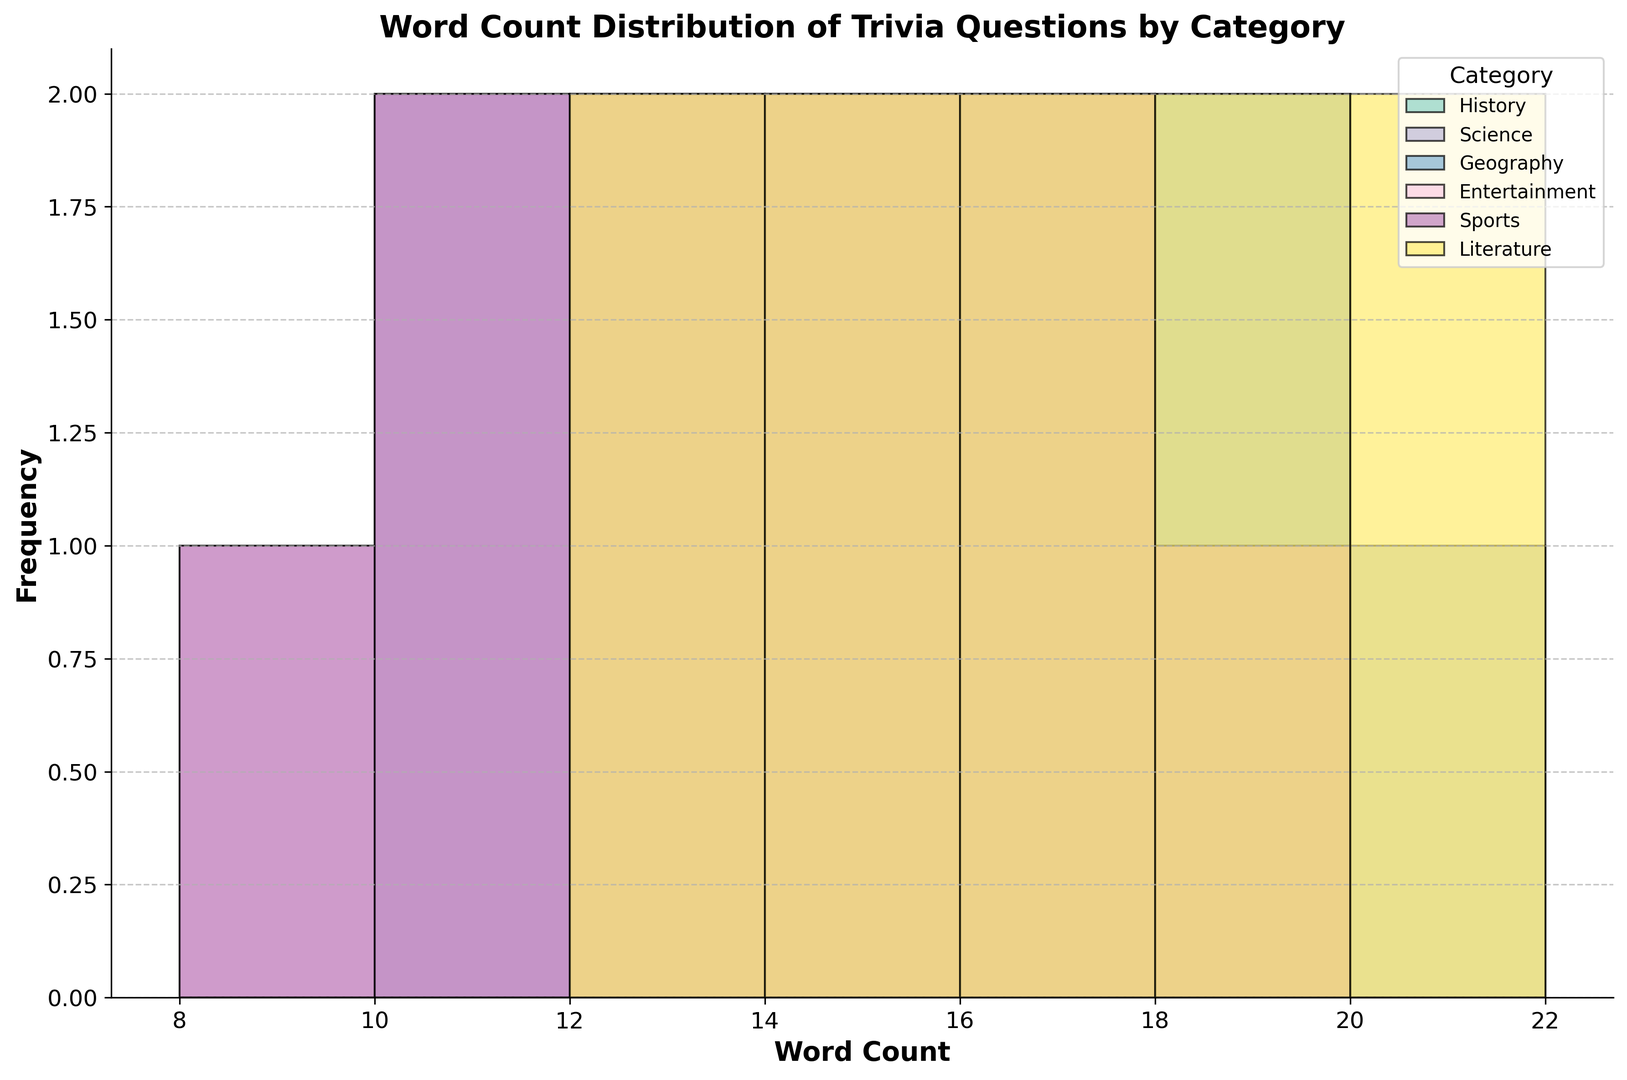What is the most frequent word count for History questions? By examining the histogram for the History category, look for the tallest bar which represents the word count with the highest frequency.
Answer: 15 Which category has the widest range of word counts? Determine the range for each category by subtracting the smallest word count from the largest word count within each category on the histogram.
Answer: Literature How many categories have trivia questions with a minimum of 9 words? Look at each category's histogram to see if there is a bar starting at 9 words. Count the number of categories that have a bar corresponding to 9 words.
Answer: 2 Which category has the highest frequency of 18-word questions? Identify the 18-word bar for each category and compare their heights. The category with the tallest bar at 18 words has the highest frequency.
Answer: Science Which category has the smallest variation in word counts? Inspect the spread of bars for each category. The category with the narrowest spread (minor difference between minimum and maximum word counts) has the smallest variation.
Answer: Sports What is the total count of trivia questions in the Entertainment category? Count the total height of all bars in the Entertainment histogram.
Answer: 10 Is the frequency of 13-word questions higher in the Geography category or the Sports category? Compare the heights of the 13-word bars in both the Geography and Sports categories.
Answer: Geography Which word count appears in all categories? Check each category's histogram to see which word count has at least one bar for every category.
Answer: 12 How does the distribution of trivia questions for Literature differ from Science based on word count? Compare the histograms for Literature and Science, looking at the number and height of bars at each word count.
Answer: Literature spans 12-21 words, Science spans 11-20 words, Literature has a taller peak at 16 and beyond What is the average word count for the History category if looking at the midpoints of the bins? Calculate the midpoint of each bin (10, 12, 14, 16, 18, 20), then multiply each by the frequency before summing them up and dividing by the total number of questions. (5*10 + 0*12 + 1*14 + 2*16 + 4*18 + 3*20)/10
Answer: 16 